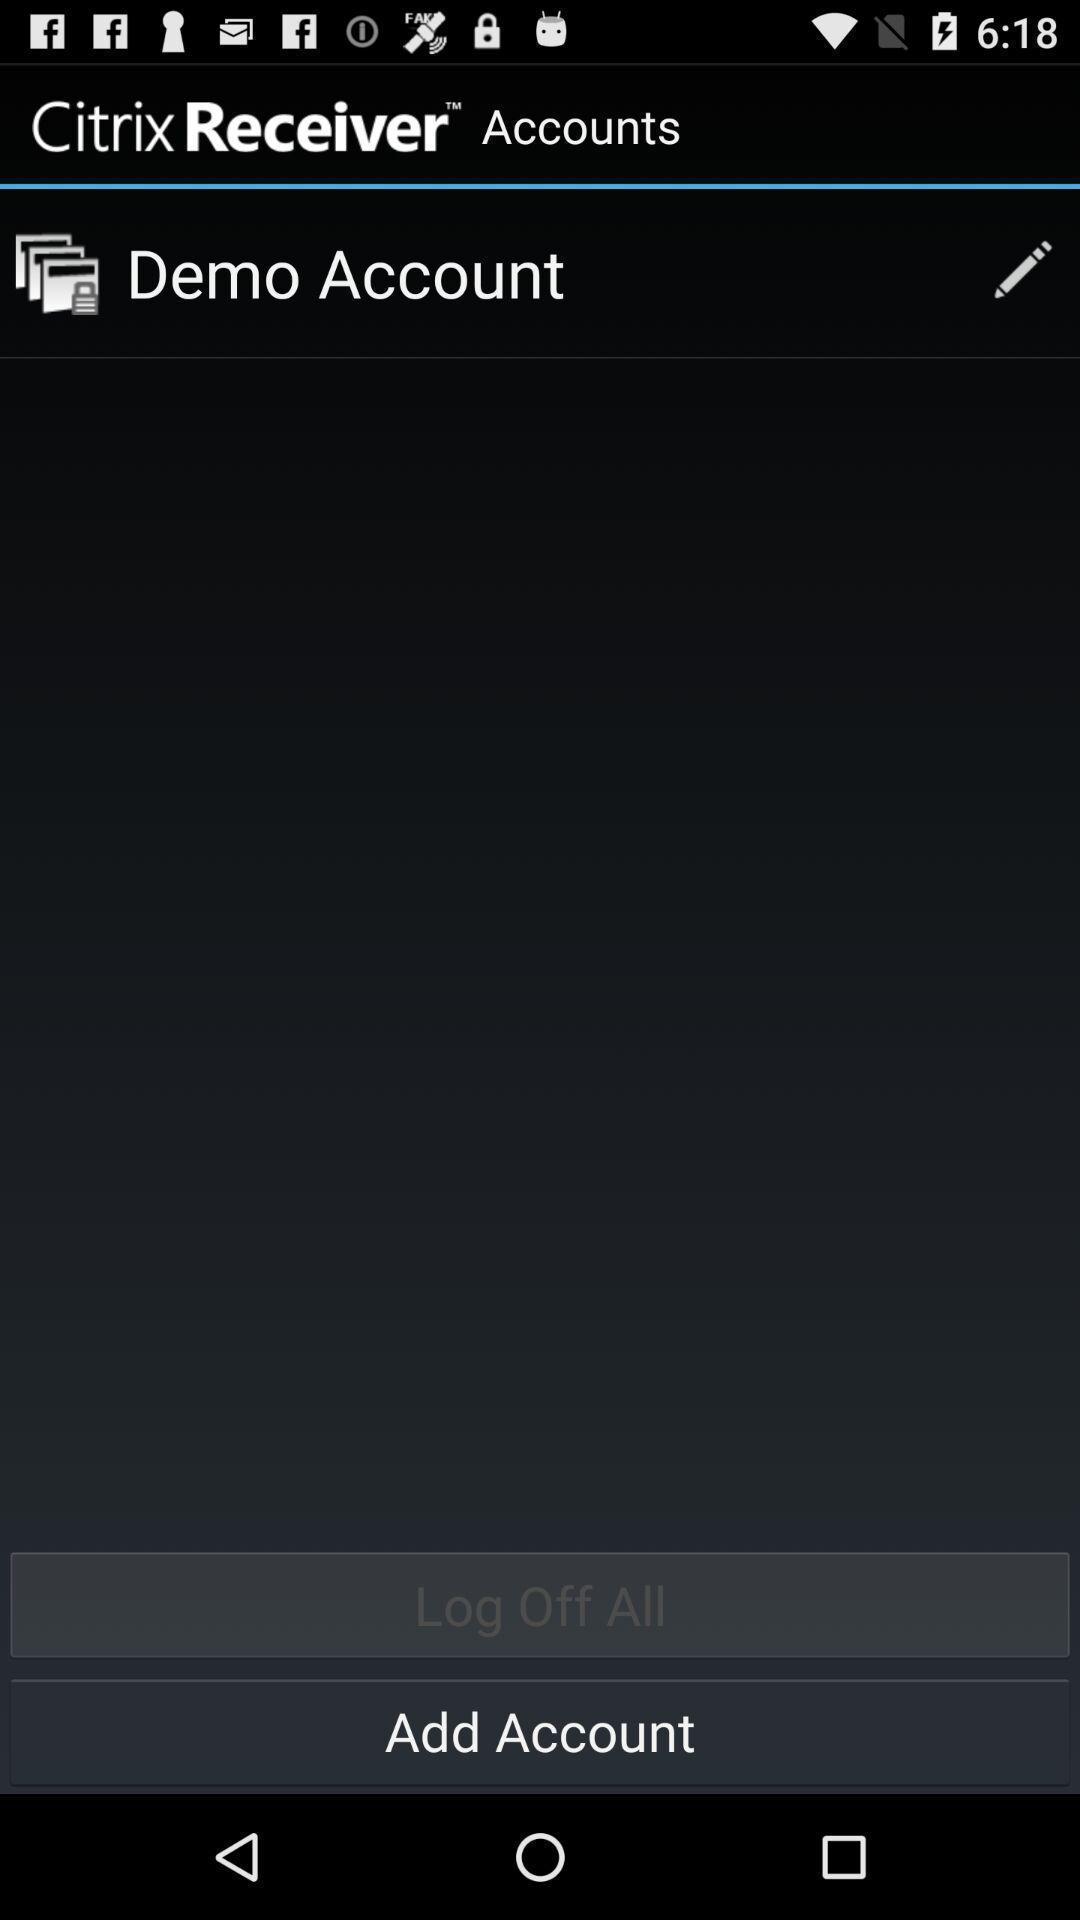Tell me what you see in this picture. Screen shows add accounts details. 